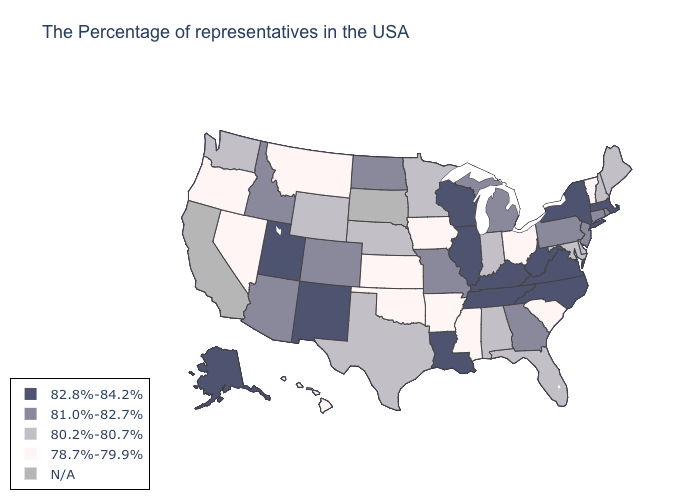Among the states that border Florida , which have the lowest value?
Write a very short answer. Alabama. Name the states that have a value in the range 78.7%-79.9%?
Quick response, please. Vermont, South Carolina, Ohio, Mississippi, Arkansas, Iowa, Kansas, Oklahoma, Montana, Nevada, Oregon, Hawaii. What is the highest value in states that border Florida?
Concise answer only. 81.0%-82.7%. Name the states that have a value in the range 81.0%-82.7%?
Quick response, please. Rhode Island, Connecticut, New Jersey, Pennsylvania, Georgia, Michigan, Missouri, North Dakota, Colorado, Arizona, Idaho. Does New Jersey have the lowest value in the USA?
Quick response, please. No. Name the states that have a value in the range 80.2%-80.7%?
Be succinct. Maine, New Hampshire, Delaware, Maryland, Florida, Indiana, Alabama, Minnesota, Nebraska, Texas, Wyoming, Washington. What is the value of Alabama?
Quick response, please. 80.2%-80.7%. What is the highest value in the MidWest ?
Concise answer only. 82.8%-84.2%. Name the states that have a value in the range 82.8%-84.2%?
Keep it brief. Massachusetts, New York, Virginia, North Carolina, West Virginia, Kentucky, Tennessee, Wisconsin, Illinois, Louisiana, New Mexico, Utah, Alaska. What is the value of Maryland?
Be succinct. 80.2%-80.7%. Name the states that have a value in the range 78.7%-79.9%?
Write a very short answer. Vermont, South Carolina, Ohio, Mississippi, Arkansas, Iowa, Kansas, Oklahoma, Montana, Nevada, Oregon, Hawaii. What is the value of South Dakota?
Answer briefly. N/A. Does the map have missing data?
Answer briefly. Yes. 